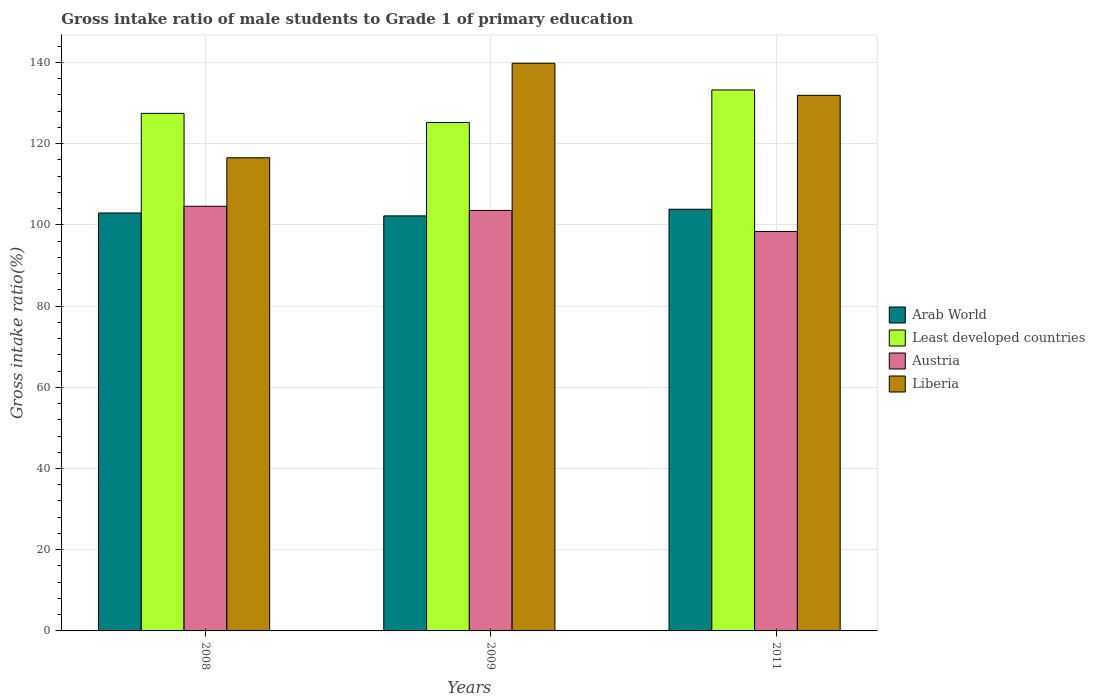Are the number of bars per tick equal to the number of legend labels?
Keep it short and to the point. Yes. How many bars are there on the 2nd tick from the left?
Keep it short and to the point. 4. What is the gross intake ratio in Least developed countries in 2008?
Your answer should be compact. 127.46. Across all years, what is the maximum gross intake ratio in Least developed countries?
Your response must be concise. 133.23. Across all years, what is the minimum gross intake ratio in Arab World?
Offer a very short reply. 102.21. In which year was the gross intake ratio in Liberia maximum?
Ensure brevity in your answer.  2009. What is the total gross intake ratio in Least developed countries in the graph?
Provide a short and direct response. 385.91. What is the difference between the gross intake ratio in Austria in 2008 and that in 2011?
Keep it short and to the point. 6.21. What is the difference between the gross intake ratio in Liberia in 2008 and the gross intake ratio in Arab World in 2011?
Your answer should be very brief. 12.68. What is the average gross intake ratio in Arab World per year?
Offer a terse response. 103. In the year 2009, what is the difference between the gross intake ratio in Austria and gross intake ratio in Arab World?
Ensure brevity in your answer.  1.34. What is the ratio of the gross intake ratio in Least developed countries in 2009 to that in 2011?
Your answer should be compact. 0.94. What is the difference between the highest and the second highest gross intake ratio in Liberia?
Ensure brevity in your answer.  7.9. What is the difference between the highest and the lowest gross intake ratio in Austria?
Your answer should be compact. 6.21. Is it the case that in every year, the sum of the gross intake ratio in Austria and gross intake ratio in Arab World is greater than the sum of gross intake ratio in Least developed countries and gross intake ratio in Liberia?
Your answer should be compact. No. What does the 1st bar from the left in 2011 represents?
Ensure brevity in your answer.  Arab World. What does the 2nd bar from the right in 2009 represents?
Your answer should be compact. Austria. How many bars are there?
Keep it short and to the point. 12. Are the values on the major ticks of Y-axis written in scientific E-notation?
Your response must be concise. No. How many legend labels are there?
Provide a succinct answer. 4. What is the title of the graph?
Your response must be concise. Gross intake ratio of male students to Grade 1 of primary education. What is the label or title of the X-axis?
Provide a short and direct response. Years. What is the label or title of the Y-axis?
Offer a very short reply. Gross intake ratio(%). What is the Gross intake ratio(%) in Arab World in 2008?
Your response must be concise. 102.93. What is the Gross intake ratio(%) in Least developed countries in 2008?
Provide a succinct answer. 127.46. What is the Gross intake ratio(%) of Austria in 2008?
Your answer should be very brief. 104.58. What is the Gross intake ratio(%) in Liberia in 2008?
Offer a terse response. 116.52. What is the Gross intake ratio(%) of Arab World in 2009?
Provide a short and direct response. 102.21. What is the Gross intake ratio(%) of Least developed countries in 2009?
Your answer should be compact. 125.22. What is the Gross intake ratio(%) of Austria in 2009?
Your answer should be compact. 103.55. What is the Gross intake ratio(%) in Liberia in 2009?
Your answer should be very brief. 139.8. What is the Gross intake ratio(%) of Arab World in 2011?
Provide a short and direct response. 103.84. What is the Gross intake ratio(%) of Least developed countries in 2011?
Ensure brevity in your answer.  133.23. What is the Gross intake ratio(%) in Austria in 2011?
Your response must be concise. 98.38. What is the Gross intake ratio(%) of Liberia in 2011?
Your answer should be very brief. 131.9. Across all years, what is the maximum Gross intake ratio(%) in Arab World?
Provide a succinct answer. 103.84. Across all years, what is the maximum Gross intake ratio(%) in Least developed countries?
Keep it short and to the point. 133.23. Across all years, what is the maximum Gross intake ratio(%) in Austria?
Provide a short and direct response. 104.58. Across all years, what is the maximum Gross intake ratio(%) of Liberia?
Your answer should be very brief. 139.8. Across all years, what is the minimum Gross intake ratio(%) in Arab World?
Offer a terse response. 102.21. Across all years, what is the minimum Gross intake ratio(%) in Least developed countries?
Your answer should be very brief. 125.22. Across all years, what is the minimum Gross intake ratio(%) of Austria?
Provide a short and direct response. 98.38. Across all years, what is the minimum Gross intake ratio(%) of Liberia?
Keep it short and to the point. 116.52. What is the total Gross intake ratio(%) of Arab World in the graph?
Provide a succinct answer. 308.99. What is the total Gross intake ratio(%) of Least developed countries in the graph?
Offer a very short reply. 385.91. What is the total Gross intake ratio(%) of Austria in the graph?
Give a very brief answer. 306.51. What is the total Gross intake ratio(%) of Liberia in the graph?
Provide a succinct answer. 388.23. What is the difference between the Gross intake ratio(%) of Arab World in 2008 and that in 2009?
Provide a short and direct response. 0.72. What is the difference between the Gross intake ratio(%) of Least developed countries in 2008 and that in 2009?
Provide a succinct answer. 2.24. What is the difference between the Gross intake ratio(%) in Liberia in 2008 and that in 2009?
Offer a very short reply. -23.28. What is the difference between the Gross intake ratio(%) in Arab World in 2008 and that in 2011?
Ensure brevity in your answer.  -0.92. What is the difference between the Gross intake ratio(%) of Least developed countries in 2008 and that in 2011?
Give a very brief answer. -5.77. What is the difference between the Gross intake ratio(%) of Austria in 2008 and that in 2011?
Your answer should be very brief. 6.21. What is the difference between the Gross intake ratio(%) of Liberia in 2008 and that in 2011?
Your answer should be compact. -15.38. What is the difference between the Gross intake ratio(%) in Arab World in 2009 and that in 2011?
Ensure brevity in your answer.  -1.63. What is the difference between the Gross intake ratio(%) in Least developed countries in 2009 and that in 2011?
Give a very brief answer. -8.01. What is the difference between the Gross intake ratio(%) in Austria in 2009 and that in 2011?
Your response must be concise. 5.18. What is the difference between the Gross intake ratio(%) of Liberia in 2009 and that in 2011?
Your answer should be very brief. 7.9. What is the difference between the Gross intake ratio(%) of Arab World in 2008 and the Gross intake ratio(%) of Least developed countries in 2009?
Give a very brief answer. -22.29. What is the difference between the Gross intake ratio(%) in Arab World in 2008 and the Gross intake ratio(%) in Austria in 2009?
Your response must be concise. -0.62. What is the difference between the Gross intake ratio(%) of Arab World in 2008 and the Gross intake ratio(%) of Liberia in 2009?
Offer a very short reply. -36.87. What is the difference between the Gross intake ratio(%) of Least developed countries in 2008 and the Gross intake ratio(%) of Austria in 2009?
Give a very brief answer. 23.91. What is the difference between the Gross intake ratio(%) of Least developed countries in 2008 and the Gross intake ratio(%) of Liberia in 2009?
Give a very brief answer. -12.34. What is the difference between the Gross intake ratio(%) of Austria in 2008 and the Gross intake ratio(%) of Liberia in 2009?
Provide a short and direct response. -35.22. What is the difference between the Gross intake ratio(%) in Arab World in 2008 and the Gross intake ratio(%) in Least developed countries in 2011?
Offer a terse response. -30.3. What is the difference between the Gross intake ratio(%) in Arab World in 2008 and the Gross intake ratio(%) in Austria in 2011?
Offer a very short reply. 4.55. What is the difference between the Gross intake ratio(%) of Arab World in 2008 and the Gross intake ratio(%) of Liberia in 2011?
Give a very brief answer. -28.97. What is the difference between the Gross intake ratio(%) of Least developed countries in 2008 and the Gross intake ratio(%) of Austria in 2011?
Offer a terse response. 29.08. What is the difference between the Gross intake ratio(%) of Least developed countries in 2008 and the Gross intake ratio(%) of Liberia in 2011?
Ensure brevity in your answer.  -4.44. What is the difference between the Gross intake ratio(%) of Austria in 2008 and the Gross intake ratio(%) of Liberia in 2011?
Your response must be concise. -27.32. What is the difference between the Gross intake ratio(%) of Arab World in 2009 and the Gross intake ratio(%) of Least developed countries in 2011?
Your answer should be compact. -31.02. What is the difference between the Gross intake ratio(%) in Arab World in 2009 and the Gross intake ratio(%) in Austria in 2011?
Offer a very short reply. 3.84. What is the difference between the Gross intake ratio(%) of Arab World in 2009 and the Gross intake ratio(%) of Liberia in 2011?
Your answer should be very brief. -29.69. What is the difference between the Gross intake ratio(%) of Least developed countries in 2009 and the Gross intake ratio(%) of Austria in 2011?
Make the answer very short. 26.85. What is the difference between the Gross intake ratio(%) of Least developed countries in 2009 and the Gross intake ratio(%) of Liberia in 2011?
Make the answer very short. -6.68. What is the difference between the Gross intake ratio(%) of Austria in 2009 and the Gross intake ratio(%) of Liberia in 2011?
Make the answer very short. -28.35. What is the average Gross intake ratio(%) in Arab World per year?
Provide a succinct answer. 103. What is the average Gross intake ratio(%) of Least developed countries per year?
Your answer should be very brief. 128.64. What is the average Gross intake ratio(%) of Austria per year?
Give a very brief answer. 102.17. What is the average Gross intake ratio(%) in Liberia per year?
Make the answer very short. 129.41. In the year 2008, what is the difference between the Gross intake ratio(%) in Arab World and Gross intake ratio(%) in Least developed countries?
Your response must be concise. -24.53. In the year 2008, what is the difference between the Gross intake ratio(%) in Arab World and Gross intake ratio(%) in Austria?
Offer a very short reply. -1.65. In the year 2008, what is the difference between the Gross intake ratio(%) in Arab World and Gross intake ratio(%) in Liberia?
Give a very brief answer. -13.59. In the year 2008, what is the difference between the Gross intake ratio(%) in Least developed countries and Gross intake ratio(%) in Austria?
Keep it short and to the point. 22.88. In the year 2008, what is the difference between the Gross intake ratio(%) of Least developed countries and Gross intake ratio(%) of Liberia?
Your response must be concise. 10.94. In the year 2008, what is the difference between the Gross intake ratio(%) in Austria and Gross intake ratio(%) in Liberia?
Your answer should be very brief. -11.94. In the year 2009, what is the difference between the Gross intake ratio(%) of Arab World and Gross intake ratio(%) of Least developed countries?
Your answer should be compact. -23.01. In the year 2009, what is the difference between the Gross intake ratio(%) in Arab World and Gross intake ratio(%) in Austria?
Ensure brevity in your answer.  -1.34. In the year 2009, what is the difference between the Gross intake ratio(%) in Arab World and Gross intake ratio(%) in Liberia?
Make the answer very short. -37.59. In the year 2009, what is the difference between the Gross intake ratio(%) of Least developed countries and Gross intake ratio(%) of Austria?
Your response must be concise. 21.67. In the year 2009, what is the difference between the Gross intake ratio(%) in Least developed countries and Gross intake ratio(%) in Liberia?
Make the answer very short. -14.58. In the year 2009, what is the difference between the Gross intake ratio(%) in Austria and Gross intake ratio(%) in Liberia?
Offer a very short reply. -36.25. In the year 2011, what is the difference between the Gross intake ratio(%) in Arab World and Gross intake ratio(%) in Least developed countries?
Your answer should be very brief. -29.38. In the year 2011, what is the difference between the Gross intake ratio(%) in Arab World and Gross intake ratio(%) in Austria?
Give a very brief answer. 5.47. In the year 2011, what is the difference between the Gross intake ratio(%) of Arab World and Gross intake ratio(%) of Liberia?
Offer a terse response. -28.06. In the year 2011, what is the difference between the Gross intake ratio(%) in Least developed countries and Gross intake ratio(%) in Austria?
Your response must be concise. 34.85. In the year 2011, what is the difference between the Gross intake ratio(%) of Least developed countries and Gross intake ratio(%) of Liberia?
Provide a succinct answer. 1.33. In the year 2011, what is the difference between the Gross intake ratio(%) in Austria and Gross intake ratio(%) in Liberia?
Offer a terse response. -33.53. What is the ratio of the Gross intake ratio(%) of Arab World in 2008 to that in 2009?
Provide a short and direct response. 1.01. What is the ratio of the Gross intake ratio(%) in Least developed countries in 2008 to that in 2009?
Provide a short and direct response. 1.02. What is the ratio of the Gross intake ratio(%) in Austria in 2008 to that in 2009?
Provide a succinct answer. 1.01. What is the ratio of the Gross intake ratio(%) of Liberia in 2008 to that in 2009?
Ensure brevity in your answer.  0.83. What is the ratio of the Gross intake ratio(%) of Arab World in 2008 to that in 2011?
Your response must be concise. 0.99. What is the ratio of the Gross intake ratio(%) of Least developed countries in 2008 to that in 2011?
Your answer should be compact. 0.96. What is the ratio of the Gross intake ratio(%) of Austria in 2008 to that in 2011?
Provide a succinct answer. 1.06. What is the ratio of the Gross intake ratio(%) in Liberia in 2008 to that in 2011?
Ensure brevity in your answer.  0.88. What is the ratio of the Gross intake ratio(%) of Arab World in 2009 to that in 2011?
Provide a short and direct response. 0.98. What is the ratio of the Gross intake ratio(%) in Least developed countries in 2009 to that in 2011?
Keep it short and to the point. 0.94. What is the ratio of the Gross intake ratio(%) of Austria in 2009 to that in 2011?
Offer a terse response. 1.05. What is the ratio of the Gross intake ratio(%) of Liberia in 2009 to that in 2011?
Keep it short and to the point. 1.06. What is the difference between the highest and the second highest Gross intake ratio(%) of Arab World?
Your answer should be compact. 0.92. What is the difference between the highest and the second highest Gross intake ratio(%) of Least developed countries?
Your answer should be very brief. 5.77. What is the difference between the highest and the second highest Gross intake ratio(%) of Liberia?
Ensure brevity in your answer.  7.9. What is the difference between the highest and the lowest Gross intake ratio(%) of Arab World?
Offer a very short reply. 1.63. What is the difference between the highest and the lowest Gross intake ratio(%) in Least developed countries?
Your answer should be very brief. 8.01. What is the difference between the highest and the lowest Gross intake ratio(%) in Austria?
Your answer should be very brief. 6.21. What is the difference between the highest and the lowest Gross intake ratio(%) of Liberia?
Offer a terse response. 23.28. 